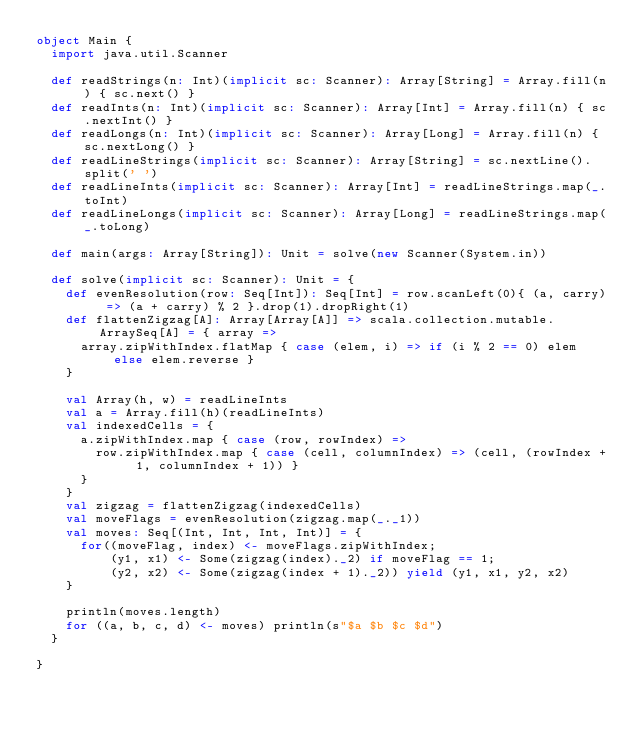Convert code to text. <code><loc_0><loc_0><loc_500><loc_500><_Scala_>object Main {
  import java.util.Scanner

  def readStrings(n: Int)(implicit sc: Scanner): Array[String] = Array.fill(n) { sc.next() }
  def readInts(n: Int)(implicit sc: Scanner): Array[Int] = Array.fill(n) { sc.nextInt() }
  def readLongs(n: Int)(implicit sc: Scanner): Array[Long] = Array.fill(n) { sc.nextLong() }
  def readLineStrings(implicit sc: Scanner): Array[String] = sc.nextLine().split(' ')
  def readLineInts(implicit sc: Scanner): Array[Int] = readLineStrings.map(_.toInt)
  def readLineLongs(implicit sc: Scanner): Array[Long] = readLineStrings.map(_.toLong)

  def main(args: Array[String]): Unit = solve(new Scanner(System.in))

  def solve(implicit sc: Scanner): Unit = {
    def evenResolution(row: Seq[Int]): Seq[Int] = row.scanLeft(0){ (a, carry) => (a + carry) % 2 }.drop(1).dropRight(1)
    def flattenZigzag[A]: Array[Array[A]] => scala.collection.mutable.ArraySeq[A] = { array =>
      array.zipWithIndex.flatMap { case (elem, i) => if (i % 2 == 0) elem else elem.reverse }
    }

    val Array(h, w) = readLineInts
    val a = Array.fill(h)(readLineInts)
    val indexedCells = {
      a.zipWithIndex.map { case (row, rowIndex) =>
        row.zipWithIndex.map { case (cell, columnIndex) => (cell, (rowIndex + 1, columnIndex + 1)) }
      }
    }
    val zigzag = flattenZigzag(indexedCells)
    val moveFlags = evenResolution(zigzag.map(_._1))
    val moves: Seq[(Int, Int, Int, Int)] = {
      for((moveFlag, index) <- moveFlags.zipWithIndex;
          (y1, x1) <- Some(zigzag(index)._2) if moveFlag == 1;
          (y2, x2) <- Some(zigzag(index + 1)._2)) yield (y1, x1, y2, x2)
    }

    println(moves.length)
    for ((a, b, c, d) <- moves) println(s"$a $b $c $d")
  }

}
</code> 